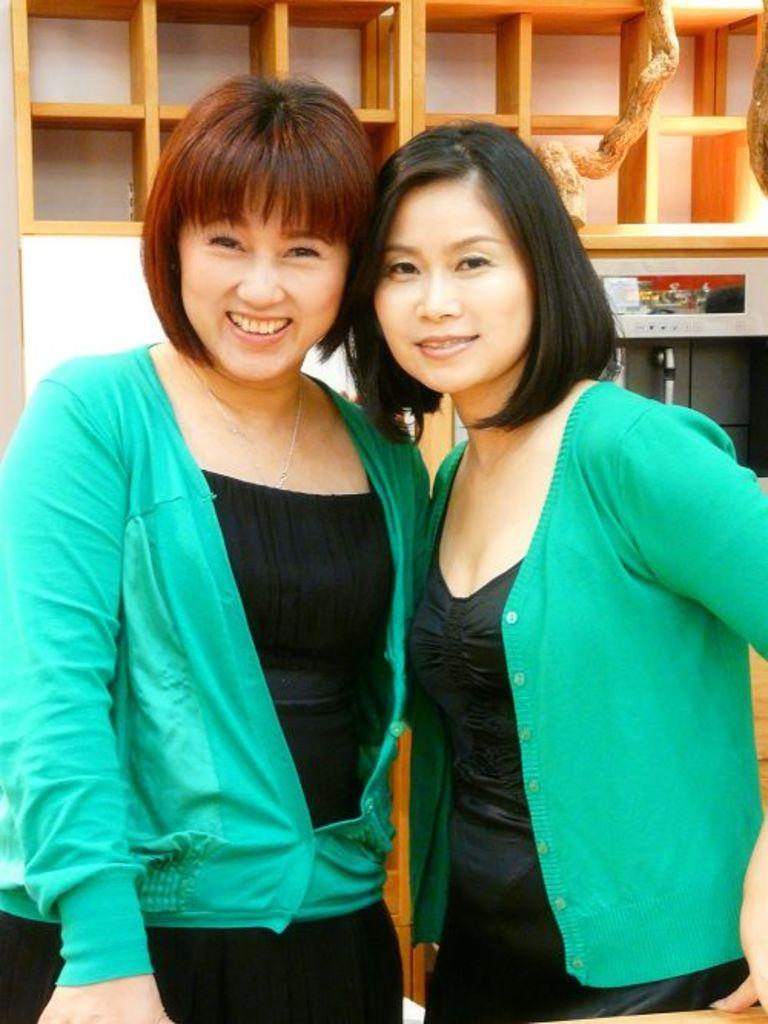How many people are in the image? There are two girls in the image. What are the girls doing in the image? The girls are standing together. What are the girls wearing in the image? The girls are wearing the same costume. What can be seen in the background of the image? There is a shelf visible in the background of the image. What type of liquid is being poured by the girls in the image? There is no liquid being poured in the image; the girls are simply standing together and wearing the same costume. 